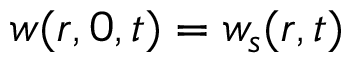<formula> <loc_0><loc_0><loc_500><loc_500>w ( r , 0 , t ) = w _ { s } ( r , t )</formula> 